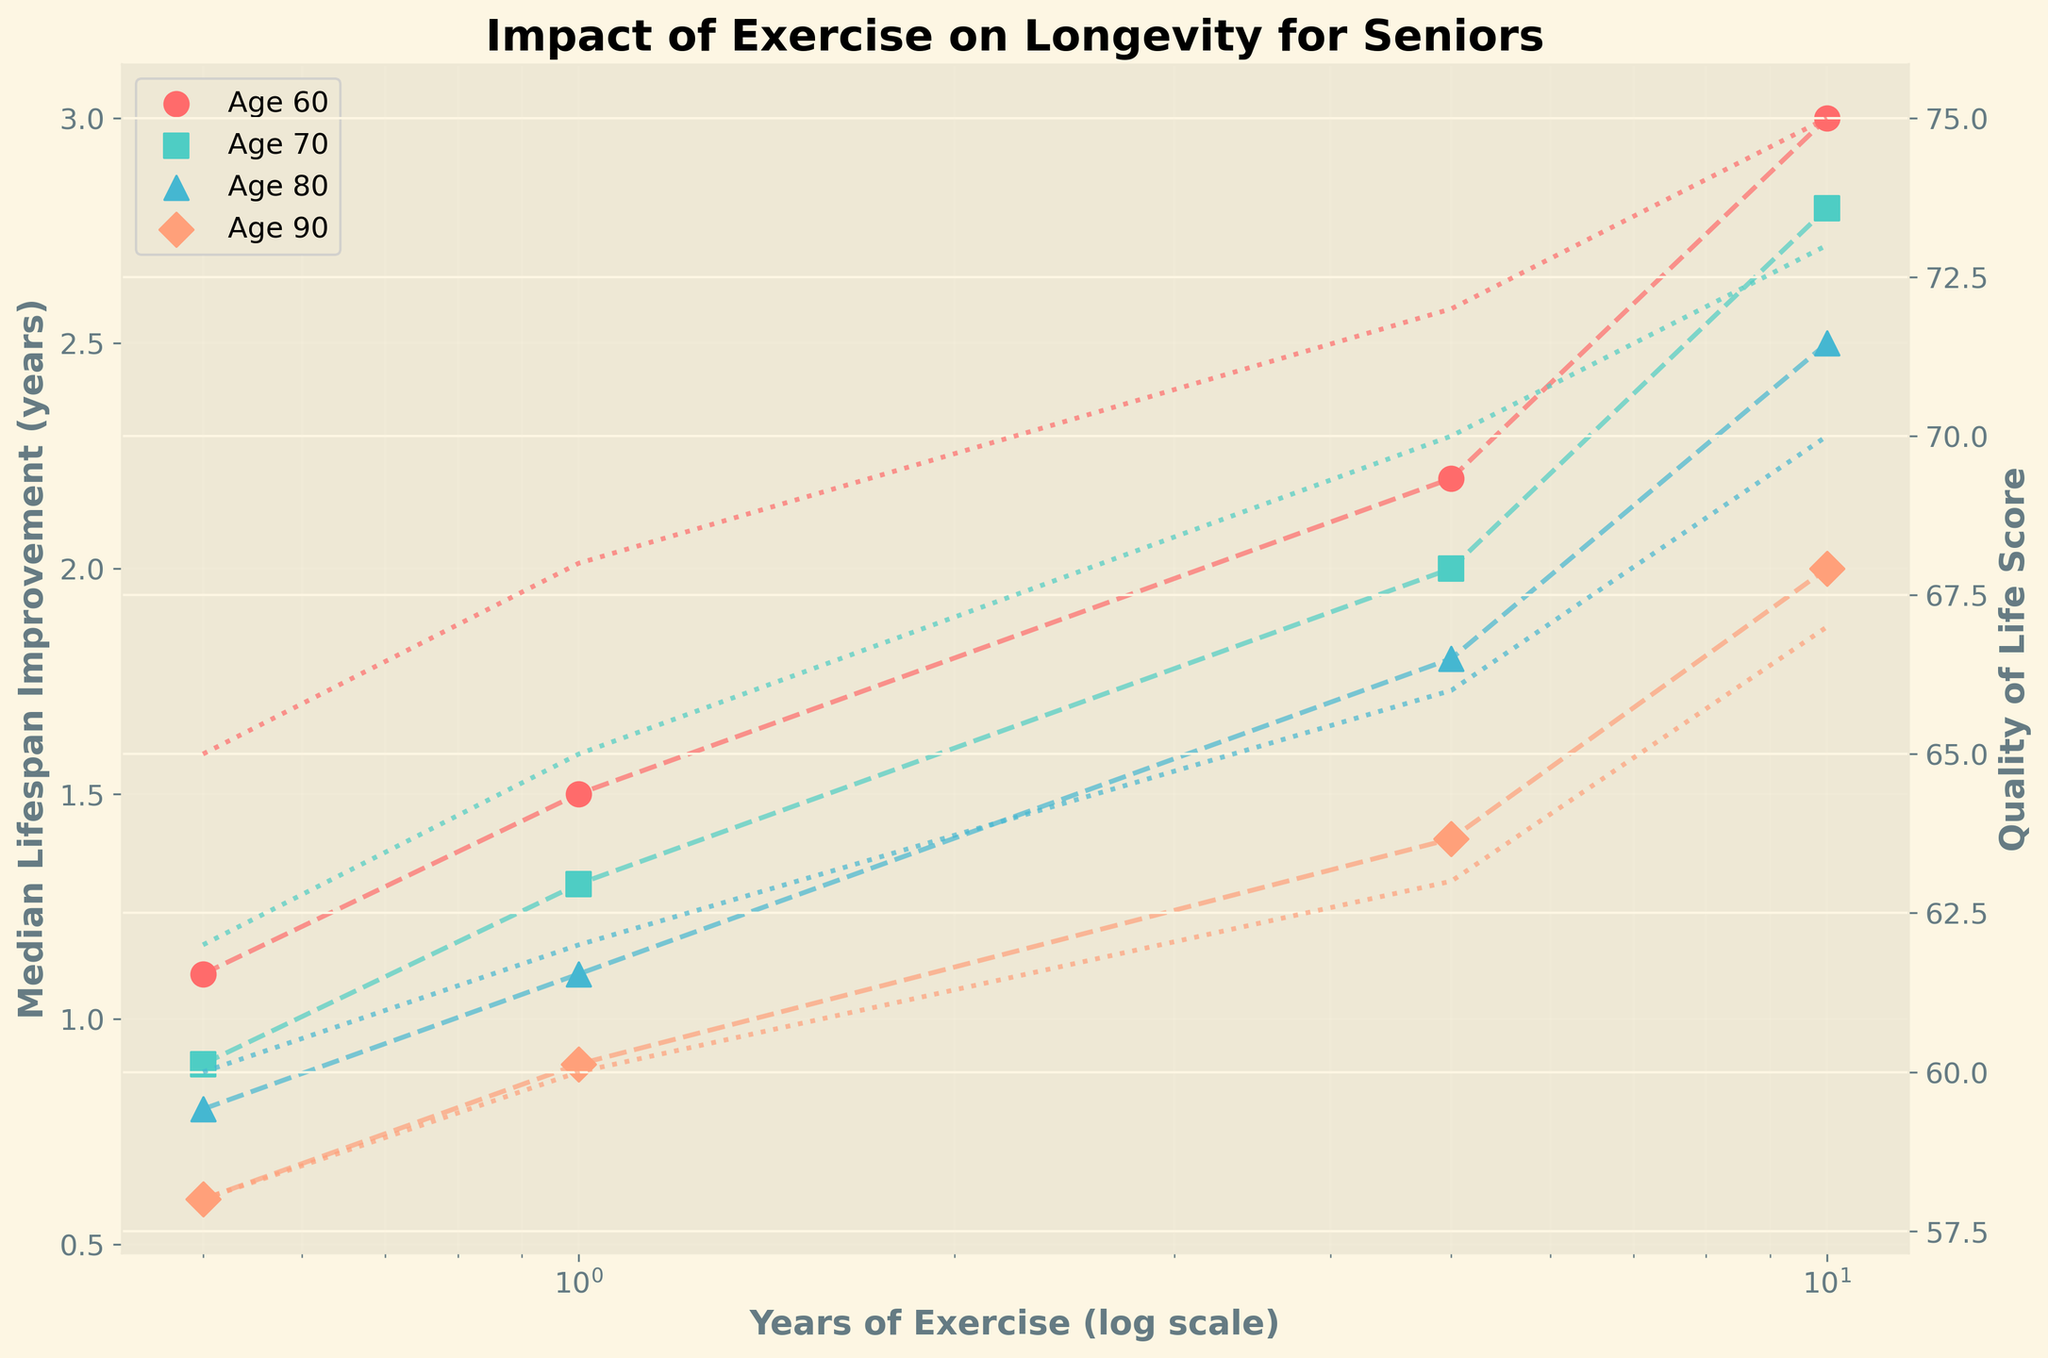What is the title of the plot? The plot title is usually at the top center of the figure in a bold font size, indicating the main subject of the plot. Here, it reads "Impact of Exercise on Longevity for Seniors" indicating it shows the effects of exercise on lifespan and quality of life in seniors.
Answer: Impact of Exercise on Longevity for Seniors How do years of exercise impact median lifespan improvement at age 60? By examining the plot, we see a positive relationship between years of exercise and median lifespan improvement. At age 60, the scatter points and line show increasing improvement as exercise years increase. Specifically, at 0.5 years of exercise there's about a 1.1-year improvement, which increases to 3 years with 10 years of exercise.
Answer: More years of exercise lead to greater median lifespan improvement What is the quality of life score at 10 years of exercise for seniors aged 80? Observing the curve specific to age 80, follow the 10 years of exercise position up to the dotted line which represents the quality of life score. The plot shows the quality of life score at 10 years of exercise reaches 70.
Answer: 70 Which age group shows the highest median lifespan improvement with 5 years of exercise? To find the highest median lifespan improvement for 5 years of exercise, compare the values across all age groups at the 5-year mark. Age 60 shows the highest improvement, slightly above the other groups at around 2.2 years.
Answer: Age 60 How does the quality of life score change from 1 year to 10 years of exercise for seniors aged 90? Looking at the plot for age 90, at 1 year of exercise, the quality of life score is about 60. At 10 years of exercise, it increases to 67. The difference is 67 - 60 = 7, showing an improvement.
Answer: Increases by 7 At which age does exercise have the smallest effect on median lifespan improvement at 0.5 years of exercise? Checking the scatter points at 0.5 years of exercise across different age groups, age 90 shows the smallest effect on median lifespan improvement, which is about 0.6 years.
Answer: Age 90 What trend do you observe in the quality of life scores with increasing years of exercise across all age groups? Across all age groups, the quality of life scores show a more or less increasing trend with more years of exercise. Each age group shows a positive correlation between exercise duration and quality of life.
Answer: Increasing trend 